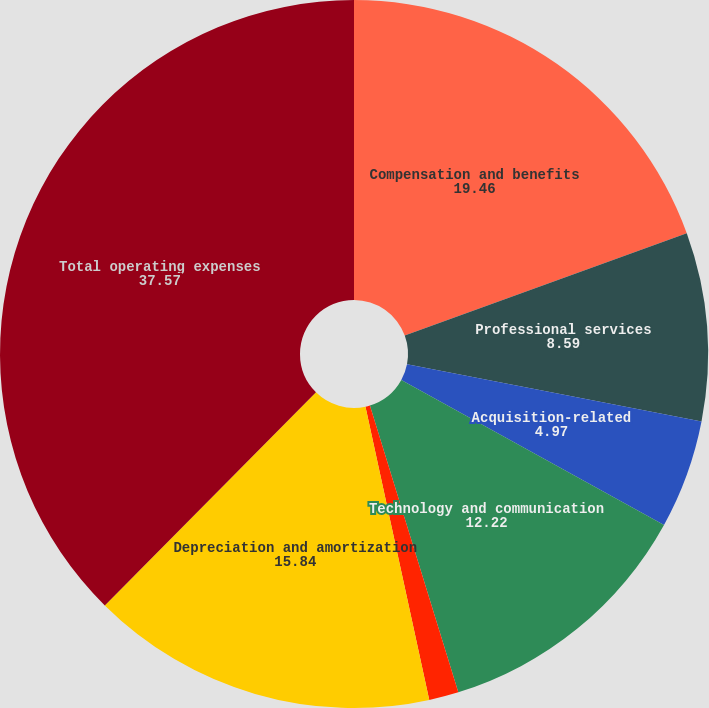Convert chart to OTSL. <chart><loc_0><loc_0><loc_500><loc_500><pie_chart><fcel>Compensation and benefits<fcel>Professional services<fcel>Acquisition-related<fcel>Technology and communication<fcel>Rent and occupancy<fcel>Depreciation and amortization<fcel>Total operating expenses<nl><fcel>19.46%<fcel>8.59%<fcel>4.97%<fcel>12.22%<fcel>1.35%<fcel>15.84%<fcel>37.57%<nl></chart> 